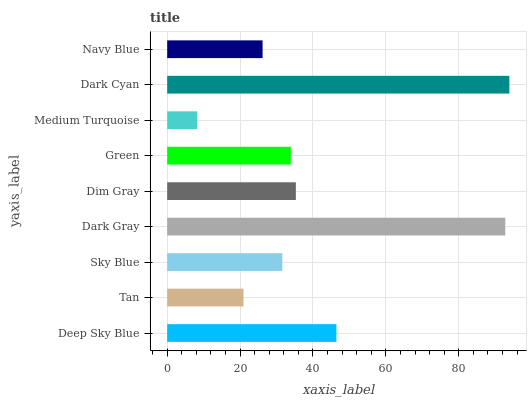Is Medium Turquoise the minimum?
Answer yes or no. Yes. Is Dark Cyan the maximum?
Answer yes or no. Yes. Is Tan the minimum?
Answer yes or no. No. Is Tan the maximum?
Answer yes or no. No. Is Deep Sky Blue greater than Tan?
Answer yes or no. Yes. Is Tan less than Deep Sky Blue?
Answer yes or no. Yes. Is Tan greater than Deep Sky Blue?
Answer yes or no. No. Is Deep Sky Blue less than Tan?
Answer yes or no. No. Is Green the high median?
Answer yes or no. Yes. Is Green the low median?
Answer yes or no. Yes. Is Medium Turquoise the high median?
Answer yes or no. No. Is Tan the low median?
Answer yes or no. No. 